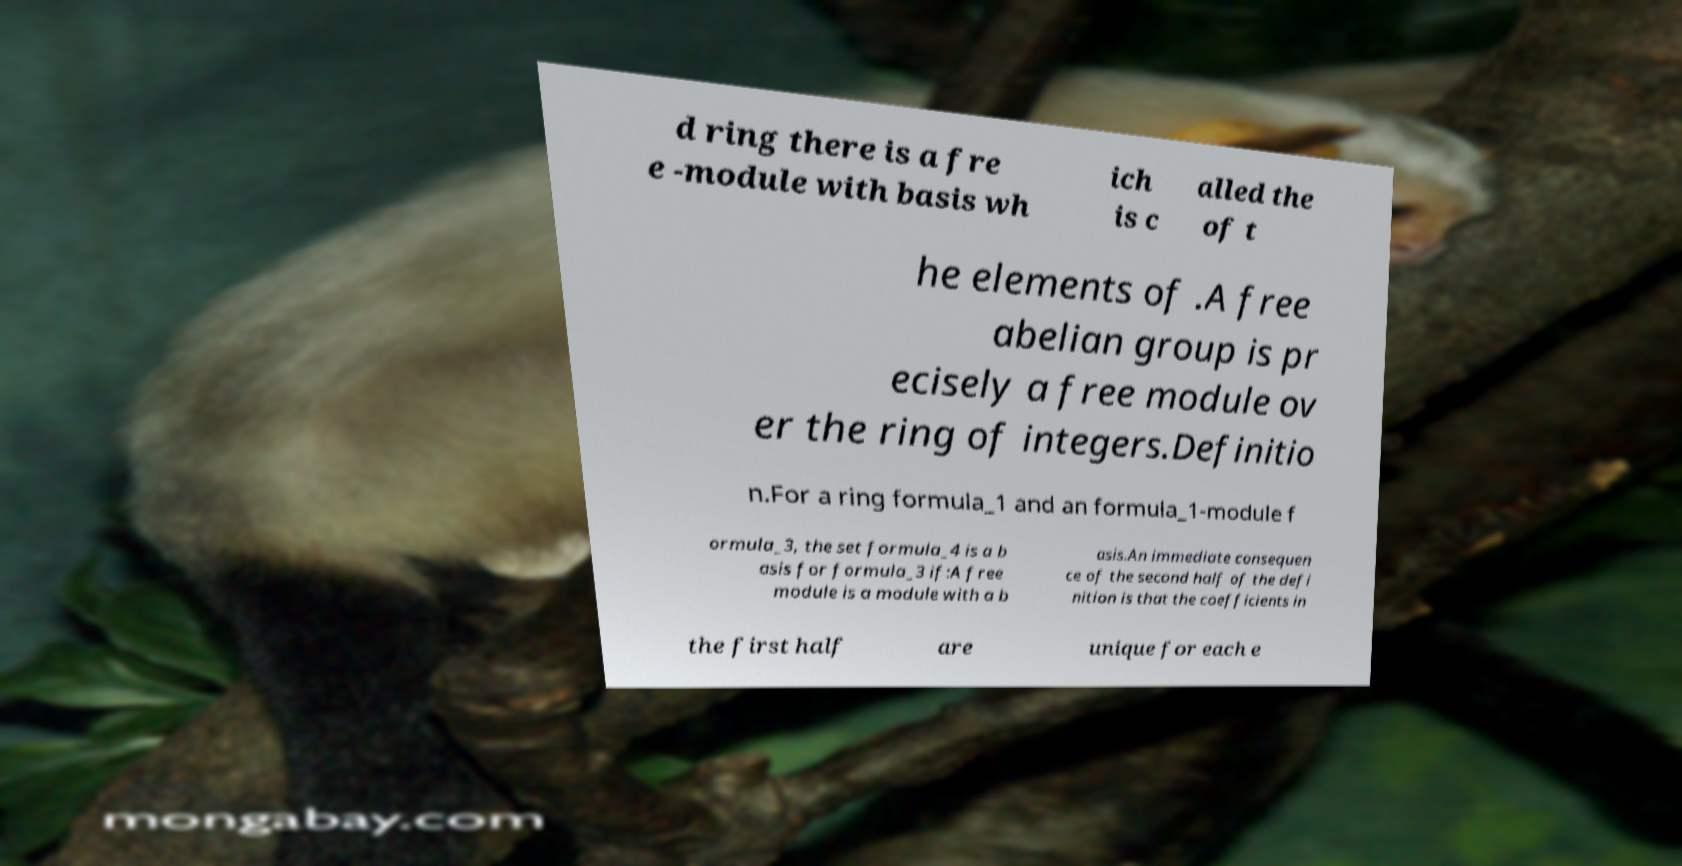What messages or text are displayed in this image? I need them in a readable, typed format. d ring there is a fre e -module with basis wh ich is c alled the of t he elements of .A free abelian group is pr ecisely a free module ov er the ring of integers.Definitio n.For a ring formula_1 and an formula_1-module f ormula_3, the set formula_4 is a b asis for formula_3 if:A free module is a module with a b asis.An immediate consequen ce of the second half of the defi nition is that the coefficients in the first half are unique for each e 